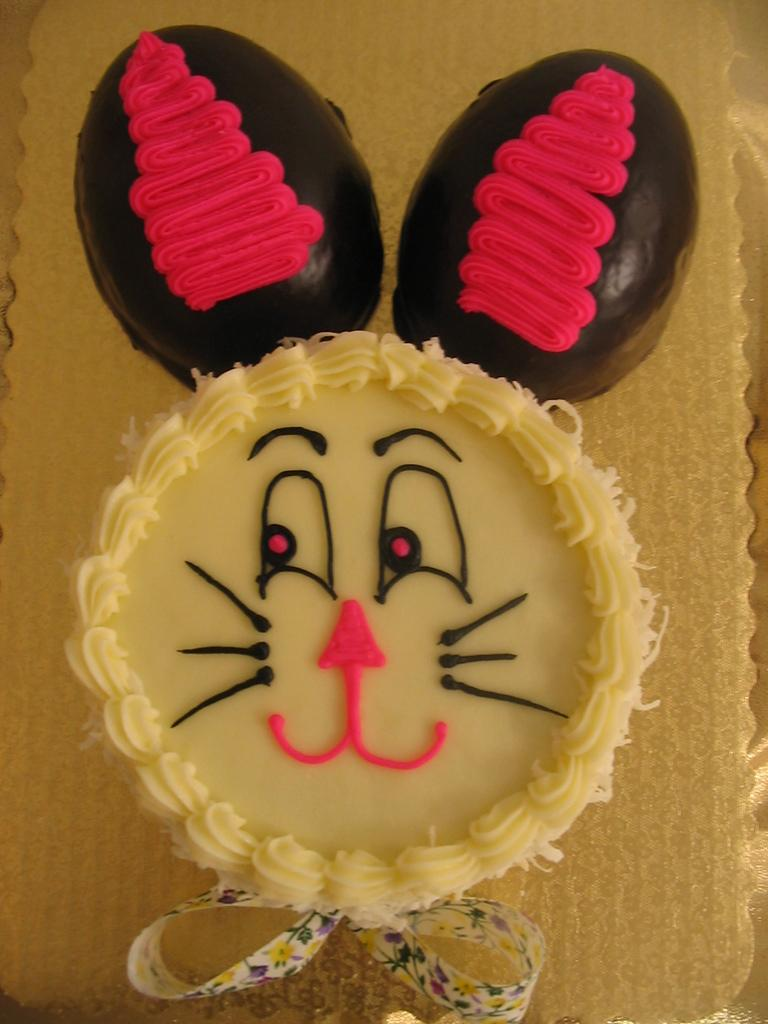What is the main subject of the image? The main subject of the image is a cake. Can you describe the location of the cake in the image? The cake is on an object in the image. What type of jewel is placed on the back of the owl in the image? There is no owl or jewel present in the image; it only features a cake on an object. 